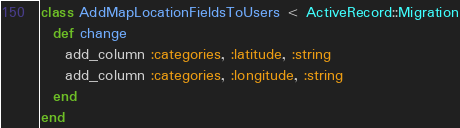Convert code to text. <code><loc_0><loc_0><loc_500><loc_500><_Ruby_>class AddMapLocationFieldsToUsers < ActiveRecord::Migration
  def change
    add_column :categories, :latitude, :string
    add_column :categories, :longitude, :string
  end
end
</code> 